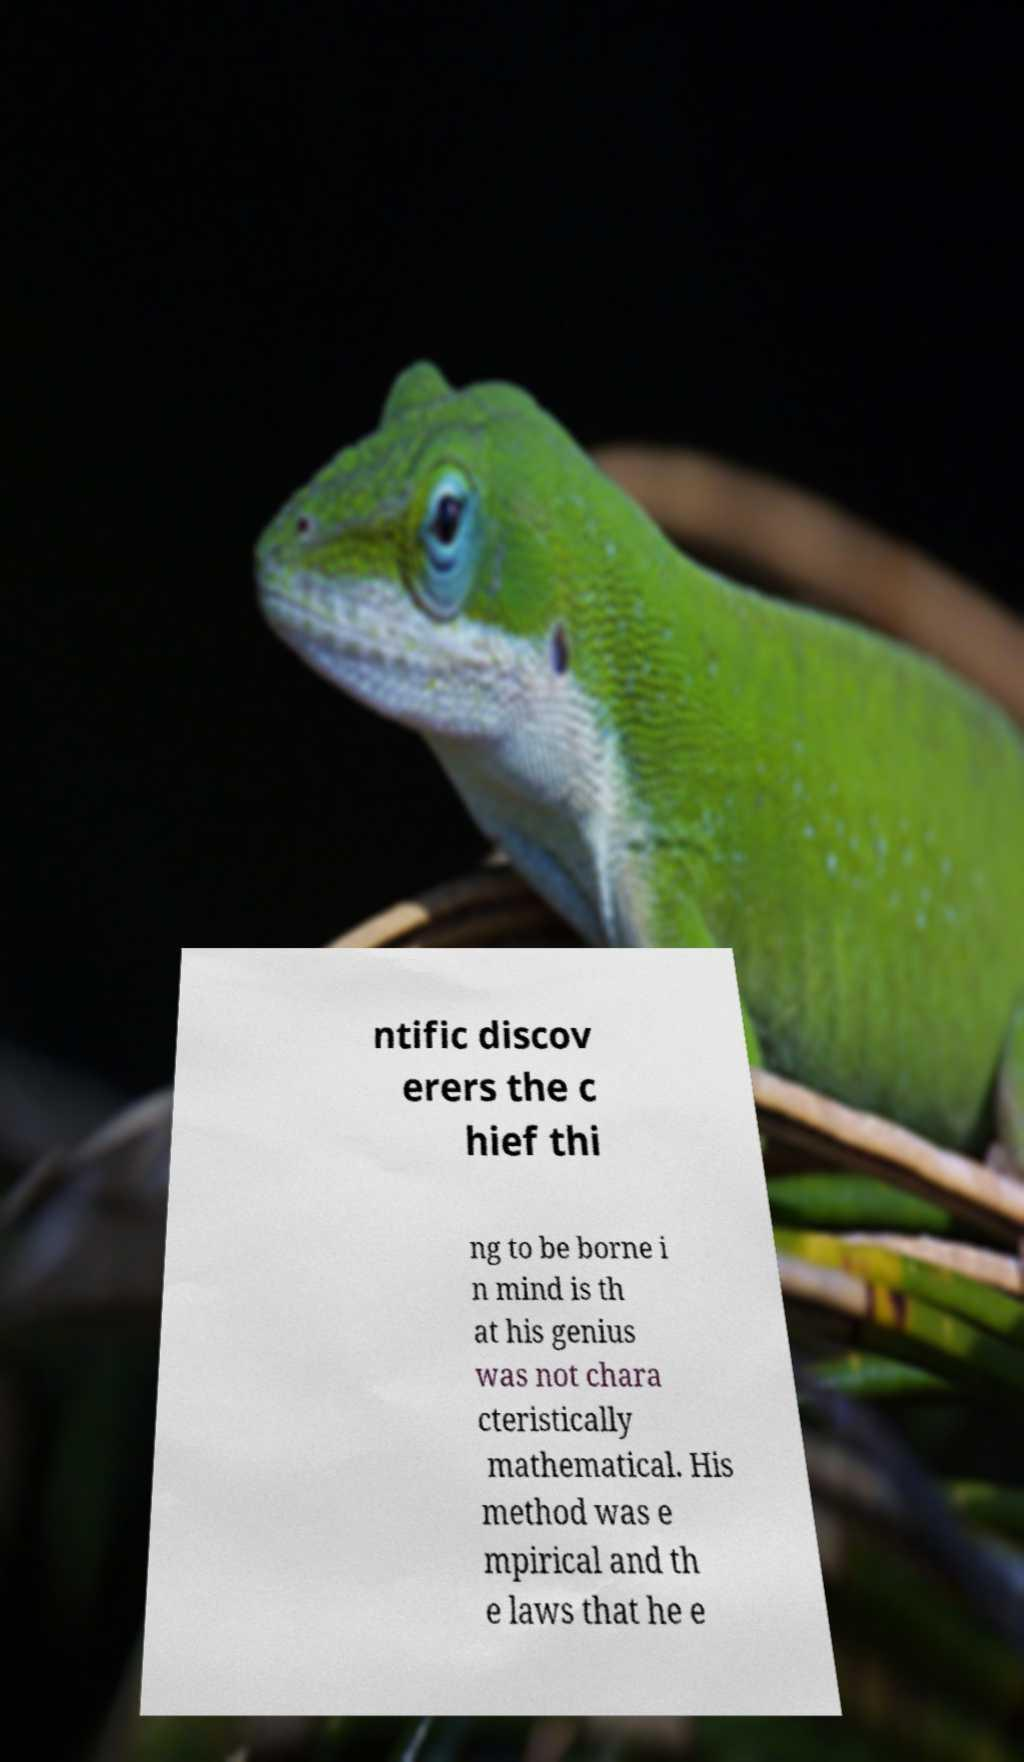There's text embedded in this image that I need extracted. Can you transcribe it verbatim? ntific discov erers the c hief thi ng to be borne i n mind is th at his genius was not chara cteristically mathematical. His method was e mpirical and th e laws that he e 